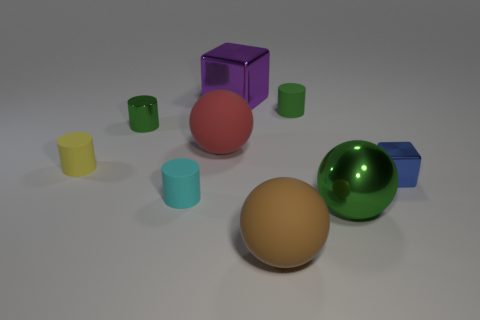Subtract all shiny cylinders. How many cylinders are left? 3 Add 1 cyan metallic objects. How many objects exist? 10 Subtract all brown cylinders. Subtract all purple balls. How many cylinders are left? 4 Subtract all cubes. How many objects are left? 7 Add 6 purple blocks. How many purple blocks exist? 7 Subtract 1 green balls. How many objects are left? 8 Subtract all large cyan spheres. Subtract all large brown matte spheres. How many objects are left? 8 Add 3 big green shiny things. How many big green shiny things are left? 4 